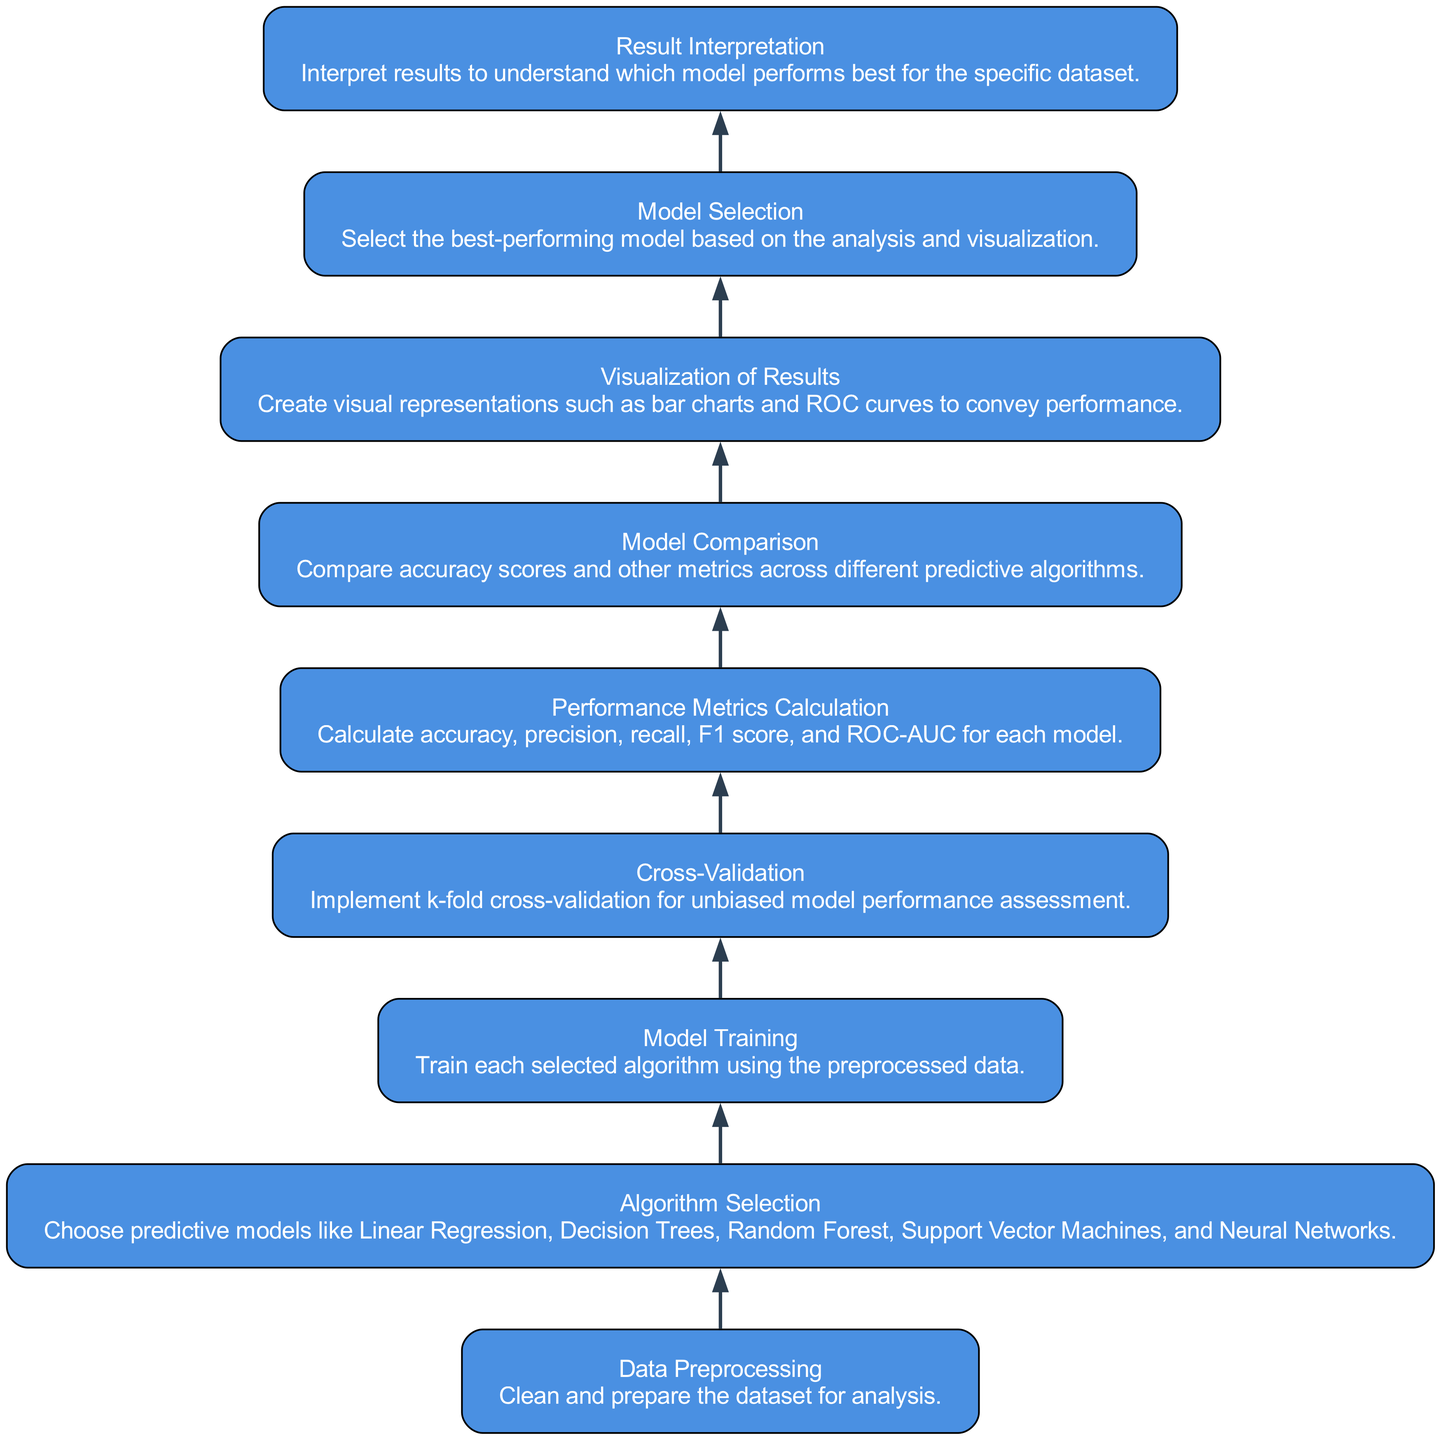What is the first step in the flow chart? The first step in the flow chart is "Data Preprocessing," which involves cleaning and preparing the dataset for analysis. This can be identified as the topmost node in the diagram that initiates the process.
Answer: Data Preprocessing How many predictive algorithms are mentioned in the diagram? The diagram lists five different predictive algorithms: Linear Regression, Decision Trees, Random Forest, Support Vector Machines, and Neural Networks. This information is found under the "Algorithm Selection" node.
Answer: Five What key activity follows Cross-Validation? The key activity that follows "Cross-Validation" is "Performance Metrics Calculation." By tracking the sequence of the nodes, "Cross-Validation" directly leads to this next step in the flow chart.
Answer: Performance Metrics Calculation Which node represents the final interpretation of results? The final interpretation of results is represented by the "Result Interpretation" node, which is located at the bottom of the flow chart, indicating it is the last step in the analysis process.
Answer: Result Interpretation Which two nodes are directly connected? The "Model Training" and "Cross-Validation" nodes are directly connected, indicating that model training must occur before implementing cross-validation in the process flow.
Answer: Model Training and Cross-Validation What metric types are calculated as part of the Performance Metrics Calculation step? The metric types calculated in this step include accuracy, precision, recall, F1 score, and ROC-AUC. These metrics are essential for assessing the performance of each predictive model and are clearly listed in the corresponding node.
Answer: Accuracy, precision, recall, F1 score, and ROC-AUC Which node shows the decision-making process after comparing models? After comparing the models, the decision-making process is shown in the "Model Selection" node, where the best-performing model is chosen based on the analysis and visualization of results.
Answer: Model Selection How does the flow of the chart progress from Visualization of Results? From "Visualization of Results," the flow progresses to "Model Selection," indicating that the results visualizations, such as bar charts and ROC curves, inform the decision on which model to select. This shows a clear directional flow in the chart.
Answer: Model Selection How many total nodes are present in the diagram? The diagram contains a total of nine nodes, each representing a specific step in the analysis of model accuracy scores from various predictive algorithms. This count includes all steps from data preprocessing to result interpretation.
Answer: Nine 